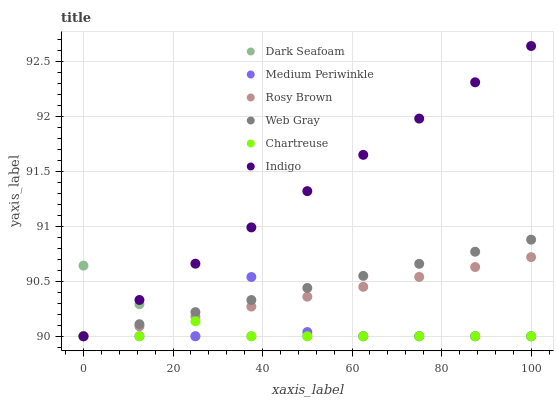Does Chartreuse have the minimum area under the curve?
Answer yes or no. Yes. Does Indigo have the maximum area under the curve?
Answer yes or no. Yes. Does Rosy Brown have the minimum area under the curve?
Answer yes or no. No. Does Rosy Brown have the maximum area under the curve?
Answer yes or no. No. Is Web Gray the smoothest?
Answer yes or no. Yes. Is Medium Periwinkle the roughest?
Answer yes or no. Yes. Is Indigo the smoothest?
Answer yes or no. No. Is Indigo the roughest?
Answer yes or no. No. Does Web Gray have the lowest value?
Answer yes or no. Yes. Does Indigo have the highest value?
Answer yes or no. Yes. Does Rosy Brown have the highest value?
Answer yes or no. No. Does Indigo intersect Medium Periwinkle?
Answer yes or no. Yes. Is Indigo less than Medium Periwinkle?
Answer yes or no. No. Is Indigo greater than Medium Periwinkle?
Answer yes or no. No. 